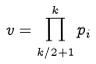<formula> <loc_0><loc_0><loc_500><loc_500>v = \prod _ { k / 2 + 1 } ^ { k } p _ { i }</formula> 